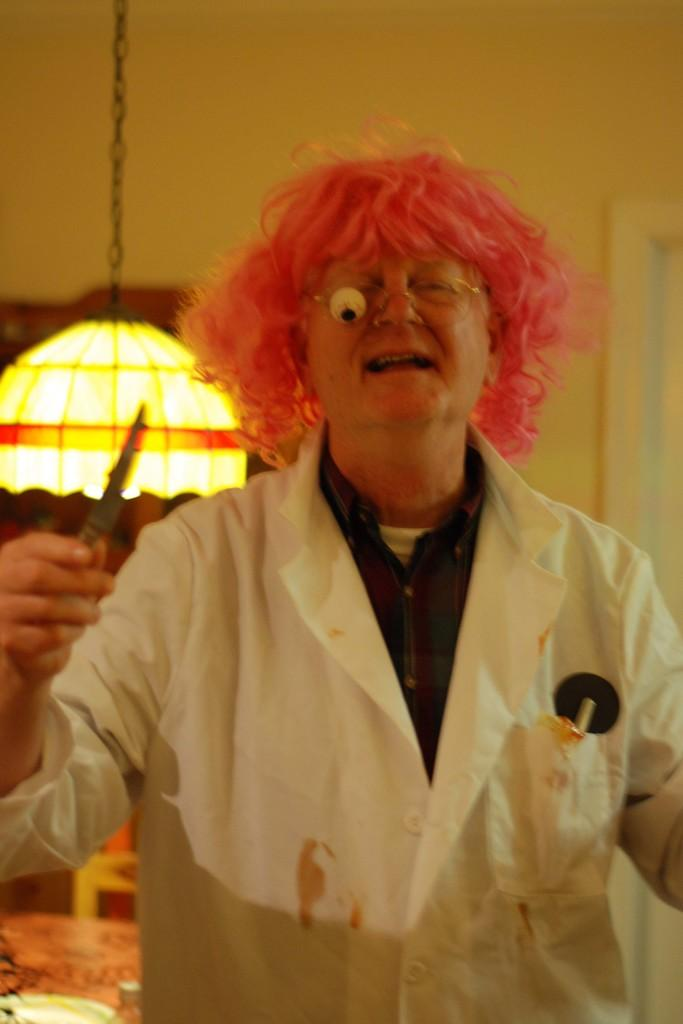What can be seen in the image? There is a person in the image. Can you describe the person's appearance? The person is wearing clothes. What is the person holding in the image? The person is holding an object. What is the source of light in the image? There is a light on the left side of the image. What type of pipe can be seen in the image? There is no pipe present in the image. How many roses are visible on the floor in the image? There are no roses or floor visible in the image; it only shows a person holding an object and a light source. 